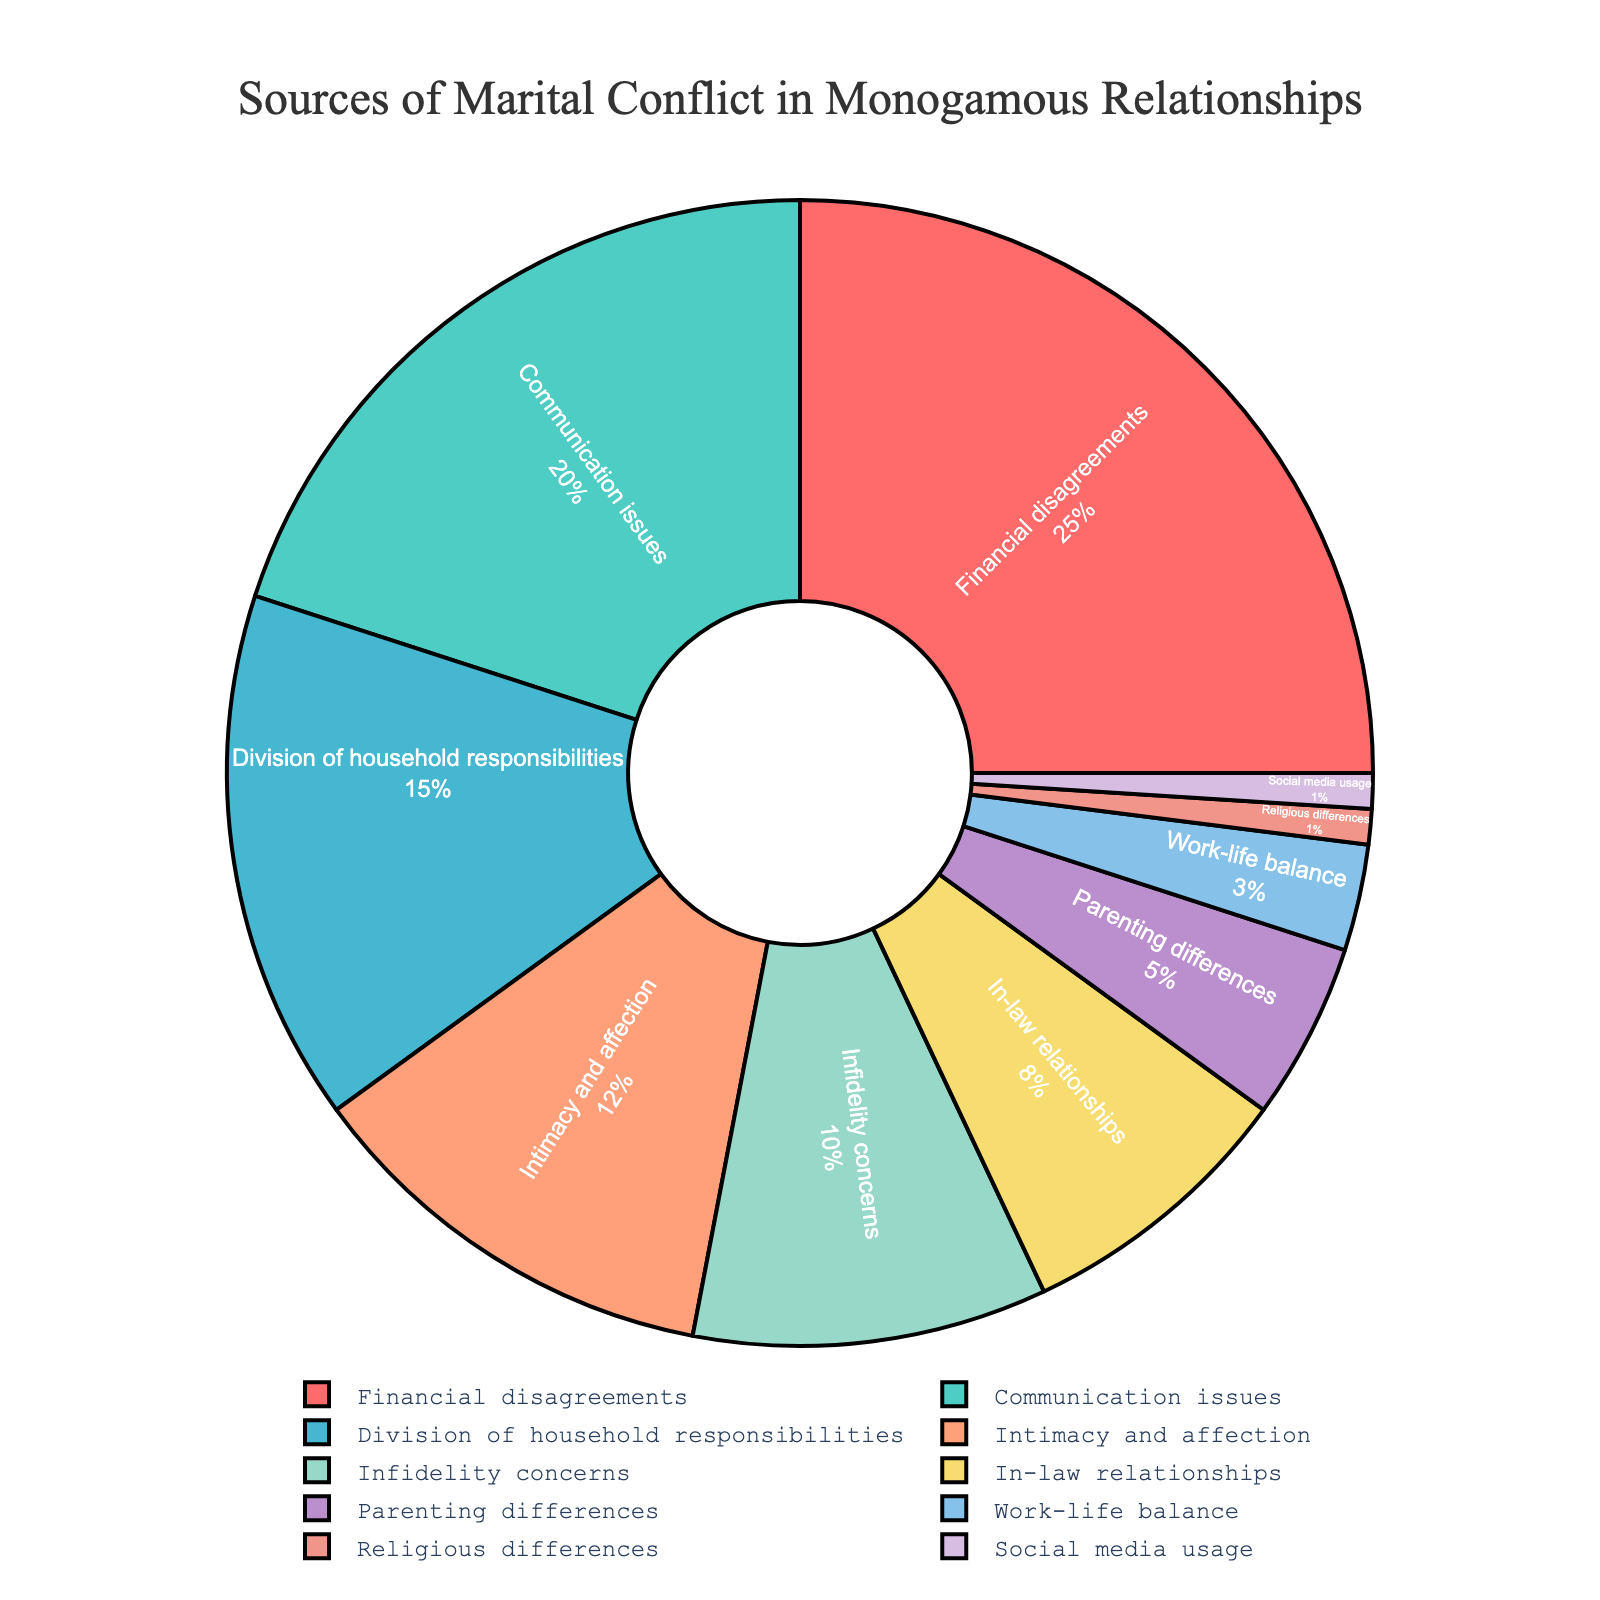Which category represents the largest source of marital conflict? Financial disagreements have the highest percentage at 25%, as seen in the pie chart.
Answer: Financial disagreements What is the combined percentage of conflicts caused by infidelity concerns and in-law relationships? Infidelity concerns account for 10% and in-law relationships account for 8%. Adding them together gives 10% + 8% = 18%.
Answer: 18% Which source of conflict is responsible for fewer issues, communication issues or intimacy and affection? Communication issues account for 20% whereas intimacy and affection account for 12%. Thus, intimacy and affection contribute to fewer issues.
Answer: Intimacy and affection Are communication issues a more significant source of conflict than division of household responsibilities? Yes, communication issues are 20%, while division of household responsibilities is 15%.
Answer: Yes What percentage of conflicts are related to parenting differences and social media usage combined? Parenting differences make up 5% and social media usage contributes to 1%. Adding them together gives 5% + 1% = 6%.
Answer: 6% How much greater is the percentage of marital conflicts due to financial disagreements compared to work-life balance? Financial disagreements are 25%, work-life balance is 3%. The difference is 25% - 3% = 22%.
Answer: 22% Which two categories combined account for nearly half of the sources of marital conflicts? Financial disagreements (25%) and communication issues (20%) together make up 25% + 20% = 45%, which is nearly half.
Answer: Financial disagreements and communication issues What visual element distinctly differentiates financial disagreements from the other categories in the pie chart? Financial disagreements are represented by the largest segment in a distinct red color, indicating it as the most significant source of conflict.
Answer: Large red segment Comparing the percentages, how many categories have a conflict percentage of less than 10%? The categories below 10% are in-law relationships (8%), parenting differences (5%), work-life balance (3%), religious differences (1%), and social media usage (1%). There are 5 such categories.
Answer: 5 Is the percentage of conflicts attributed to division of household responsibilities higher than the combined percentage of religious differences and social media usage? Yes, division of household responsibilities is 15%, while the combined percentage of religious differences (1%) and social media usage (1%) is 2%.
Answer: Yes 